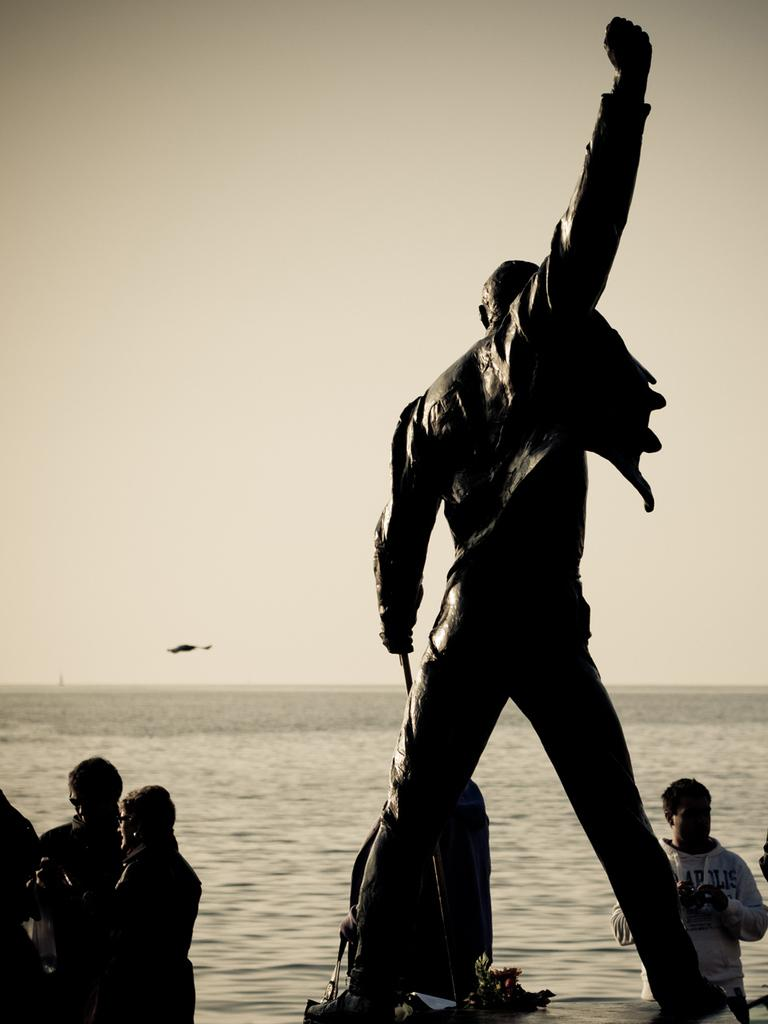What is the main subject of the image? There is a statue in the image. What is happening at the base of the statue? There are people at the bottom of the statue. What natural feature can be seen in the background of the image? The background of the image includes the sea. What else is visible in the background of the image? The sky is visible in the background of the image. What type of nut is being used as a lunch ingredient in the image? There is no nut or lunch present in the image; it features a statue with people at the base and a background that includes the sea and sky. 